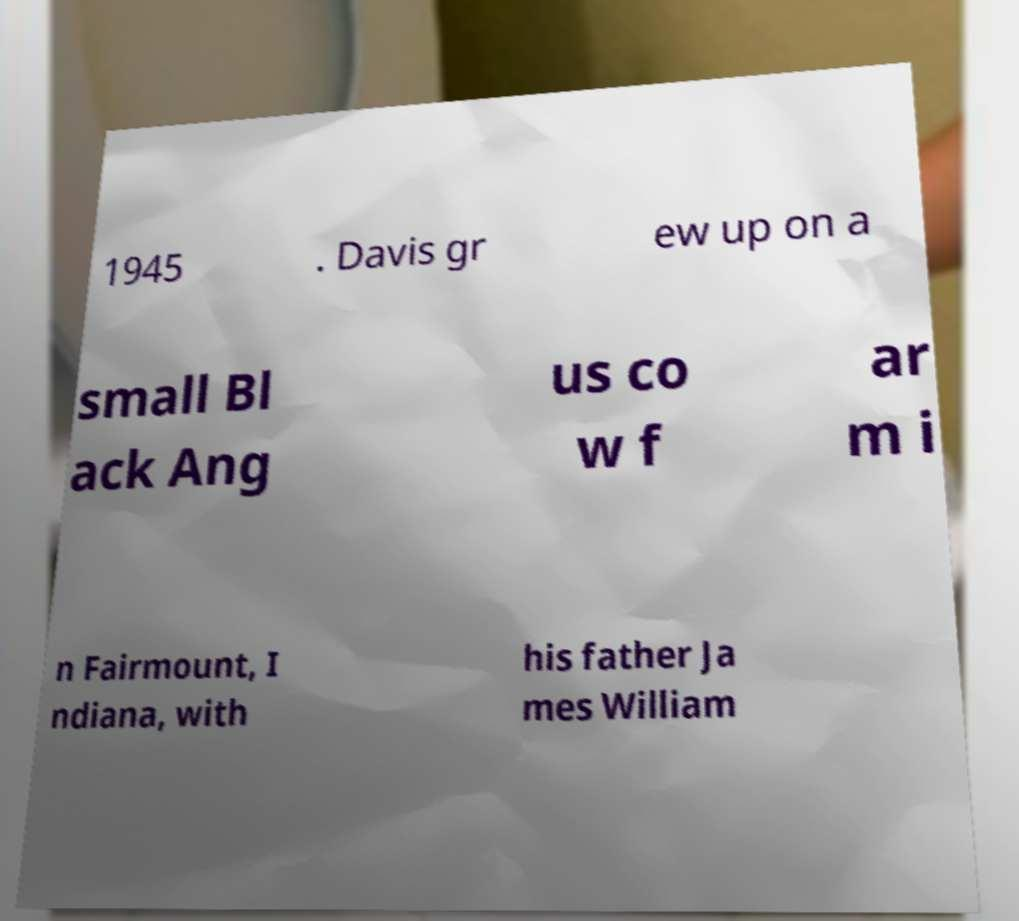Could you assist in decoding the text presented in this image and type it out clearly? 1945 . Davis gr ew up on a small Bl ack Ang us co w f ar m i n Fairmount, I ndiana, with his father Ja mes William 